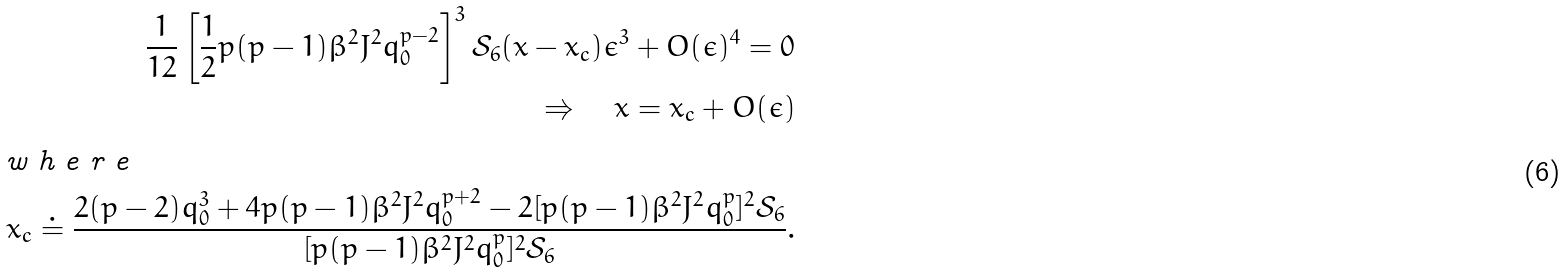<formula> <loc_0><loc_0><loc_500><loc_500>\frac { 1 } { 1 2 } \left [ \frac { 1 } { 2 } p ( p - 1 ) \beta ^ { 2 } J ^ { 2 } q _ { 0 } ^ { p - 2 } \right ] ^ { 3 } \mathcal { S } _ { 6 } ( x - x _ { c } ) \epsilon ^ { 3 } + O ( \epsilon ) ^ { 4 } = 0 \\ \Rightarrow \quad x = x _ { c } + O ( \epsilon ) \intertext { w h e r e } x _ { c } \doteq \frac { 2 ( p - 2 ) q _ { 0 } ^ { 3 } + 4 p ( p - 1 ) \beta ^ { 2 } J ^ { 2 } q _ { 0 } ^ { p + 2 } - 2 [ p ( p - 1 ) \beta ^ { 2 } J ^ { 2 } q _ { 0 } ^ { p } ] ^ { 2 } \mathcal { S } _ { 6 } } { [ p ( p - 1 ) \beta ^ { 2 } J ^ { 2 } q _ { 0 } ^ { p } ] ^ { 2 } \mathcal { S } _ { 6 } } .</formula> 